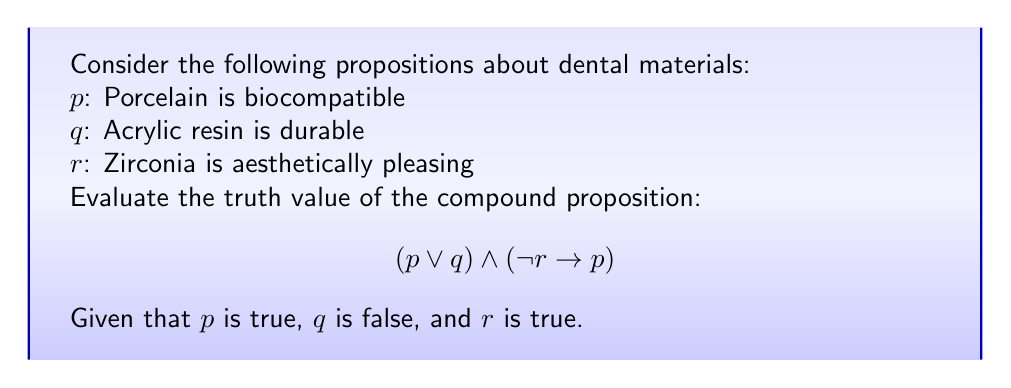Teach me how to tackle this problem. To evaluate the truth value of the compound proposition, we'll break it down into its components and use the given truth values:

1. p is true (T)
2. q is false (F)
3. r is true (T)

Let's evaluate each part of the compound proposition:

1. $(p \lor q)$:
   - This is a disjunction (OR) operation
   - p is true, q is false
   - T $\lor$ F = T

2. $(\lnot r \rightarrow p)$:
   - First, we need to evaluate $\lnot r$
   - r is true, so $\lnot r$ is false
   - Now we have F $\rightarrow$ T
   - In propositional logic, F $\rightarrow$ T is always true
   - So, $(\lnot r \rightarrow p)$ = T

3. Now we have: $(p \lor q) \land (\lnot r \rightarrow p)$
   - This is a conjunction (AND) operation
   - From steps 1 and 2, we have: T $\land$ T
   - T $\land$ T = T

Therefore, the entire compound proposition is true.
Answer: True 